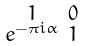Convert formula to latex. <formula><loc_0><loc_0><loc_500><loc_500>\begin{smallmatrix} 1 & 0 \\ e ^ { - \pi i \alpha } & 1 \end{smallmatrix}</formula> 